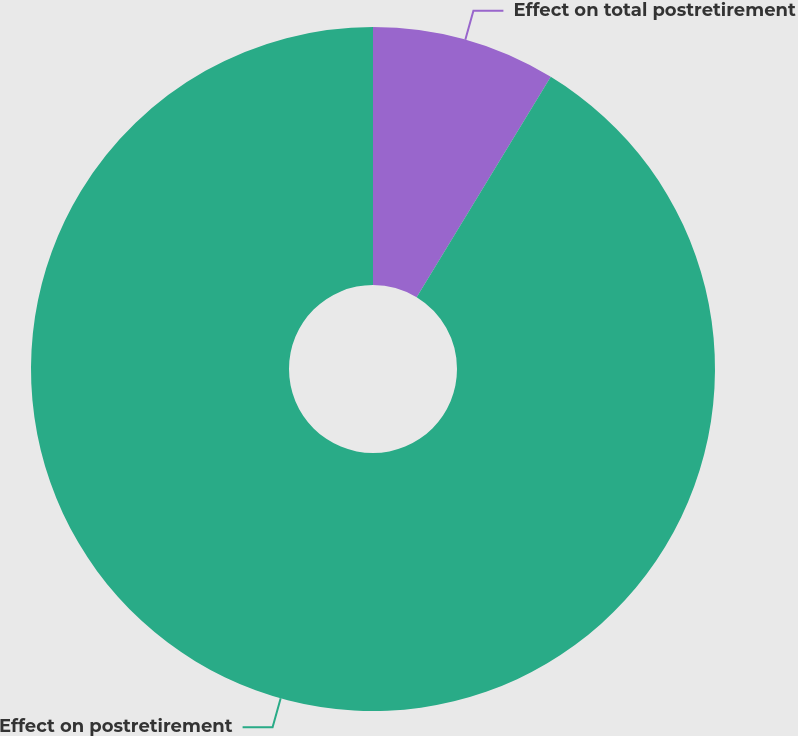Convert chart. <chart><loc_0><loc_0><loc_500><loc_500><pie_chart><fcel>Effect on total postretirement<fcel>Effect on postretirement<nl><fcel>8.7%<fcel>91.3%<nl></chart> 